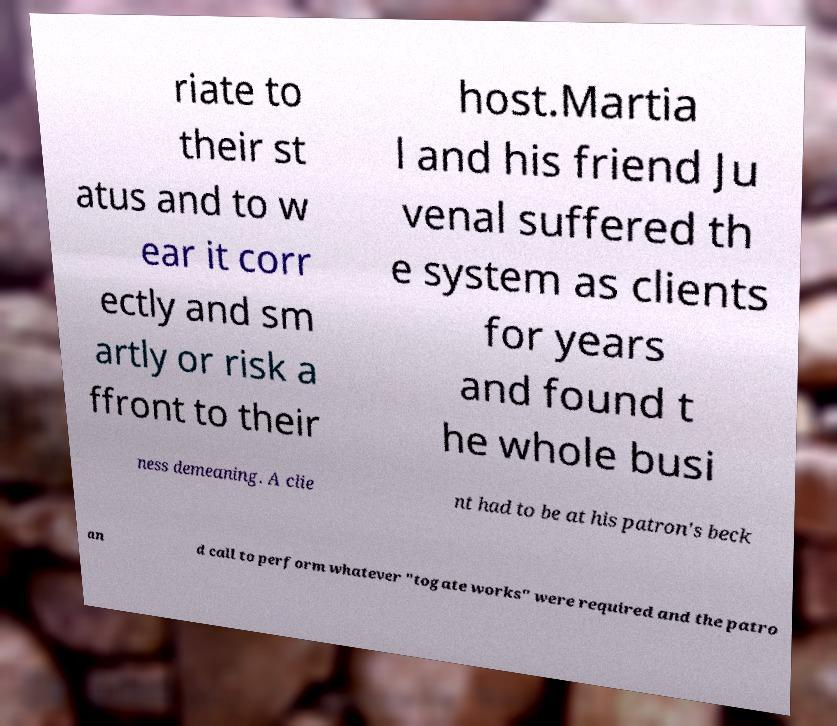For documentation purposes, I need the text within this image transcribed. Could you provide that? riate to their st atus and to w ear it corr ectly and sm artly or risk a ffront to their host.Martia l and his friend Ju venal suffered th e system as clients for years and found t he whole busi ness demeaning. A clie nt had to be at his patron's beck an d call to perform whatever "togate works" were required and the patro 